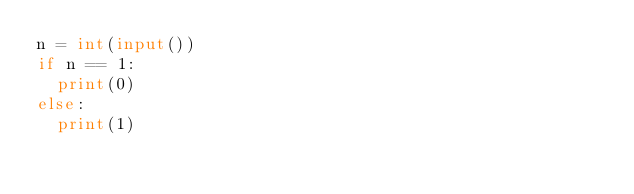<code> <loc_0><loc_0><loc_500><loc_500><_Python_>n = int(input())
if n == 1:
  print(0)
else:
  print(1)</code> 